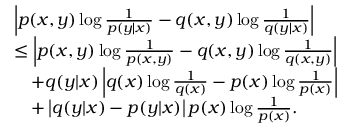<formula> <loc_0><loc_0><loc_500><loc_500>\begin{array} { r l } & { \left | p ( x , y ) \log \frac { 1 } { p ( y | x ) } - q ( x , y ) \log \frac { 1 } { q ( y | x ) } \right | } \\ & { \leq \left | p ( x , y ) \log \frac { 1 } { p ( x , y ) } - q ( x , y ) \log \frac { 1 } { q ( x , y ) } \right | } \\ & { \quad + q ( y | x ) \left | q ( x ) \log \frac { 1 } { q ( x ) } - p ( x ) \log \frac { 1 } { p ( x ) } \right | } \\ & { \quad + \left | q ( y | x ) - p ( y | x ) \right | p ( x ) \log \frac { 1 } { p ( x ) } . } \end{array}</formula> 